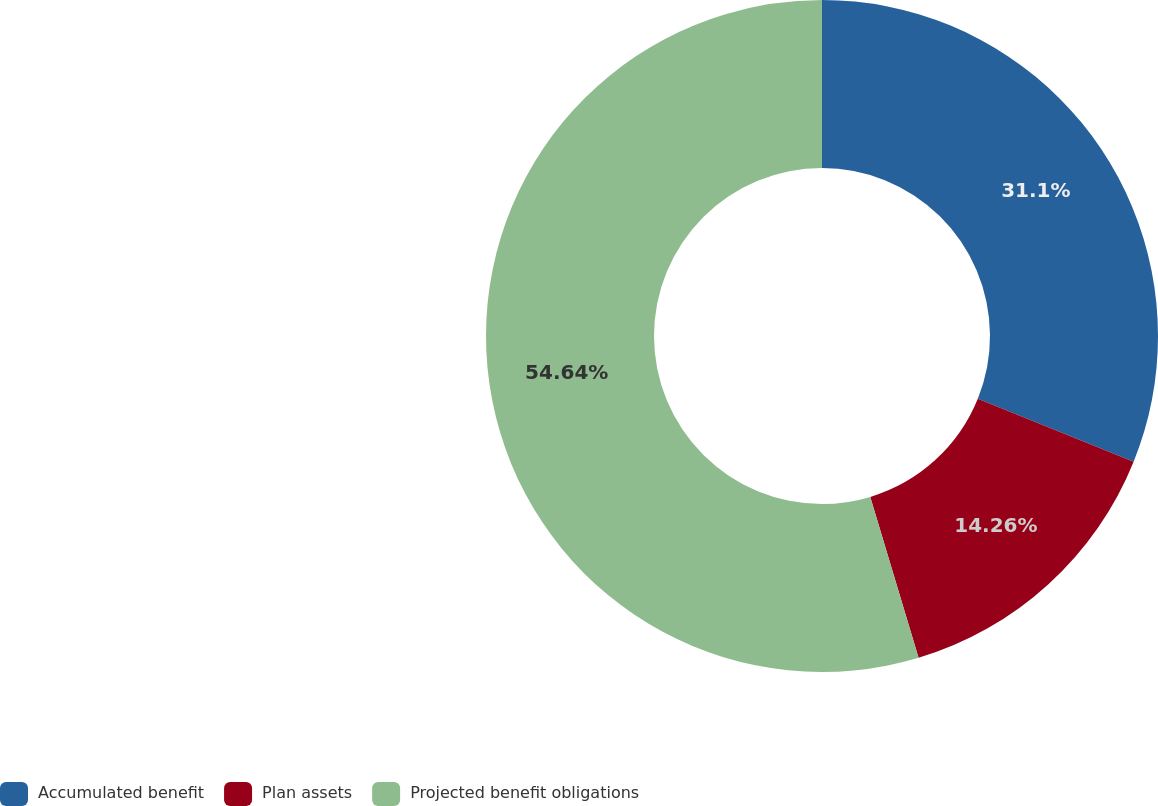Convert chart. <chart><loc_0><loc_0><loc_500><loc_500><pie_chart><fcel>Accumulated benefit<fcel>Plan assets<fcel>Projected benefit obligations<nl><fcel>31.1%<fcel>14.26%<fcel>54.64%<nl></chart> 